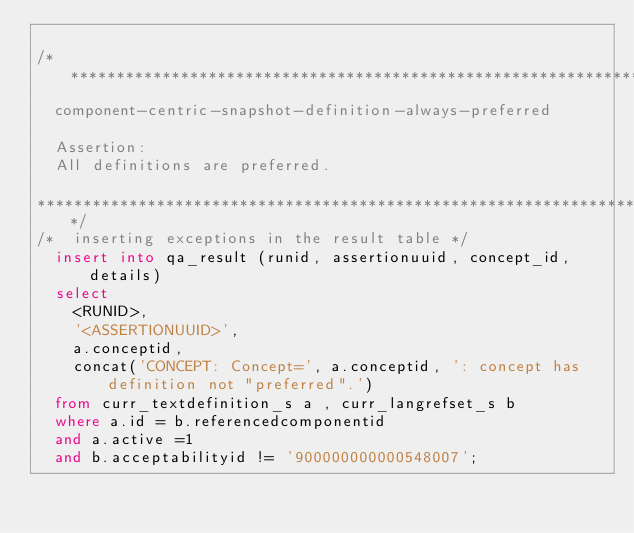Convert code to text. <code><loc_0><loc_0><loc_500><loc_500><_SQL_>
/******************************************************************************** 
	component-centric-snapshot-definition-always-preferred

	Assertion:
	All definitions are preferred.

********************************************************************************/
/* 	inserting exceptions in the result table */
	insert into qa_result (runid, assertionuuid, concept_id, details)
	select 
		<RUNID>,
		'<ASSERTIONUUID>',
		a.conceptid,
		concat('CONCEPT: Concept=', a.conceptid, ': concept has definition not "preferred".') 	
	from curr_textdefinition_s a , curr_langrefset_s b 
	where a.id = b.referencedcomponentid
	and a.active =1
	and b.acceptabilityid != '900000000000548007';	</code> 